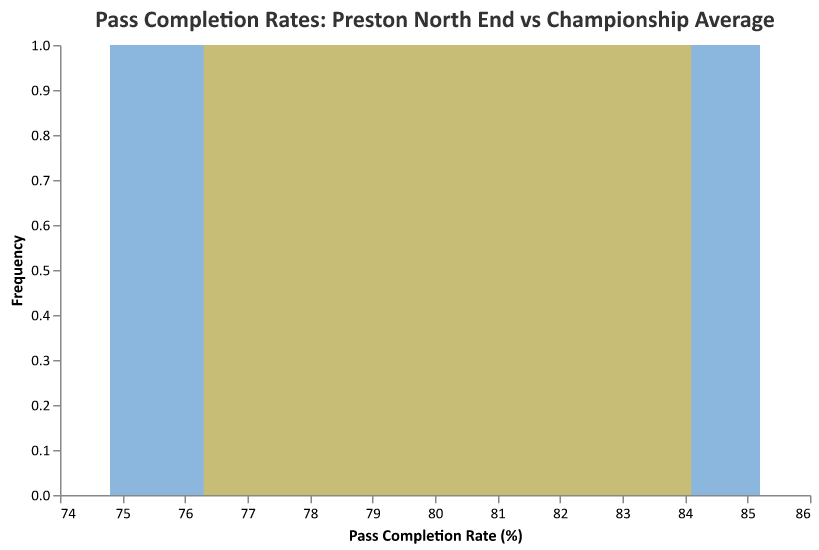What is the title of the figure? The title is displayed at the top of the figure in a larger font, indicating the main subject of the plot.
Answer: "Pass Completion Rates: Preston North End vs Championship Average" What do the colors blue and yellow represent in the plot? The blue color represents data for Preston North End players, and the yellow color represents data for Championship averages as indicated by the specific opacity and color used in the plot.
Answer: Blue: Preston North End, Yellow: Championship Average How many Preston North End players are shown in the plot? By counting the number of distinct data points labeled under "Preston North End" in the plot, we find that there are 8 data points corresponding to the players.
Answer: 8 What range of pass completion rates is covered for Preston North End players? The horizontal (x) axis covers the pass completion rates, and examining the spread of blue areas gives the range. For Preston North End, the rates range from the lowest value of 74.8% to the highest value of 85.2%.
Answer: 74.8% to 85.2% Do Preston North End midfielders generally have higher or lower pass completion rates compared to the Championship average? Observing the overlap and position of the blue (Preston North End) and yellow (Championship) area plots, it can be inferred that Preston North End midfielders generally have a slight tendency towards higher pass completion rates as the blue area has more representation towards higher values.
Answer: Higher Which player has the highest pass completion rate for Preston North End? By identifying the highest point within the blue area plot corresponding to Preston North End midfielders, Ryan Ledson has the highest pass completion rate at 85.2%.
Answer: Ryan Ledson What is the difference between the highest pass completion rate of a Preston North End midfielder and the highest Championship average? The highest pass completion rate for a Preston North End midfielder is 85.2%, and the highest Championship average shown is 84.1%. The difference is 85.2% - 84.1% = 1.1%.
Answer: 1.1% What is the median pass completion rate for the Championship average data points? By sorting the Championship average data points and finding the median value, the middle values are 80.7% and 81.0%. The median pass completion rate is the average of these two values (80.7 + 81.0) / 2 = 80.85%.
Answer: 80.85% Which has a smaller pass completion rate range, Preston North End or Championship averages? The range for Preston North End is from 74.8% to 85.2%, which is a range of 10.4%. The range for Championship averages is from 76.3% to 84.1%, which is a range of 7.8%. Comparing these ranges, Championship averages have a smaller range.
Answer: Championship averages Is there any Preston North End player with a pass completion rate lower than all the Championship averages? The lowest pass completion rate among Championship averages is 76.3%. Emil Riis Jakobsen has a pass completion rate of 74.8%, which is lower than 76.3%.
Answer: Yes 